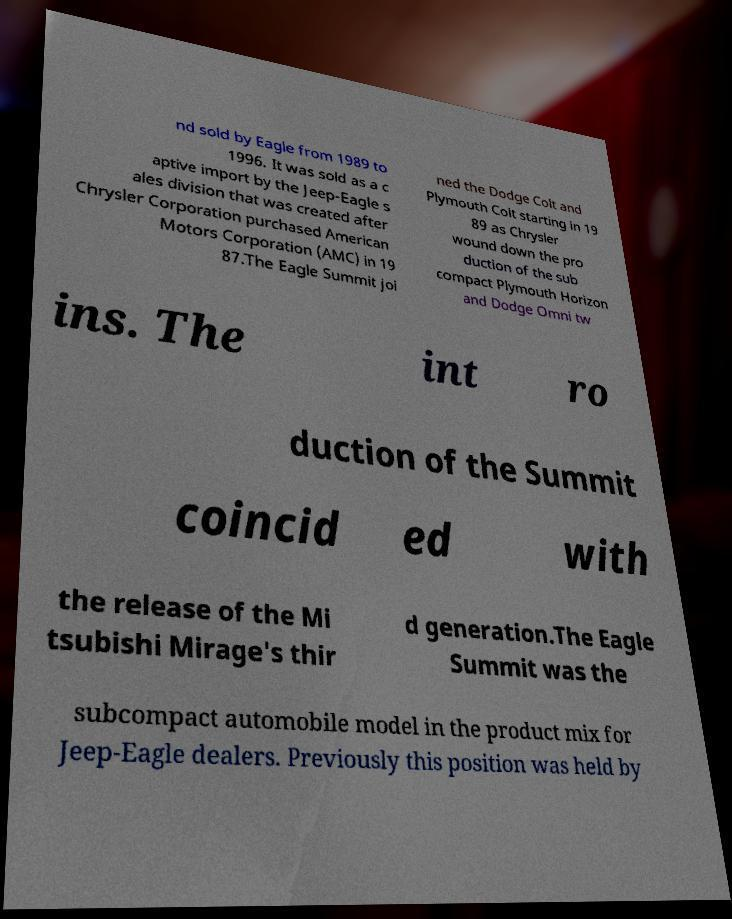Could you assist in decoding the text presented in this image and type it out clearly? nd sold by Eagle from 1989 to 1996. It was sold as a c aptive import by the Jeep-Eagle s ales division that was created after Chrysler Corporation purchased American Motors Corporation (AMC) in 19 87.The Eagle Summit joi ned the Dodge Colt and Plymouth Colt starting in 19 89 as Chrysler wound down the pro duction of the sub compact Plymouth Horizon and Dodge Omni tw ins. The int ro duction of the Summit coincid ed with the release of the Mi tsubishi Mirage's thir d generation.The Eagle Summit was the subcompact automobile model in the product mix for Jeep-Eagle dealers. Previously this position was held by 